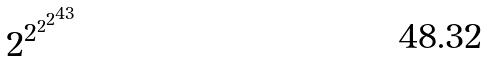<formula> <loc_0><loc_0><loc_500><loc_500>2 ^ { 2 ^ { 2 ^ { 2 ^ { 4 3 } } } }</formula> 